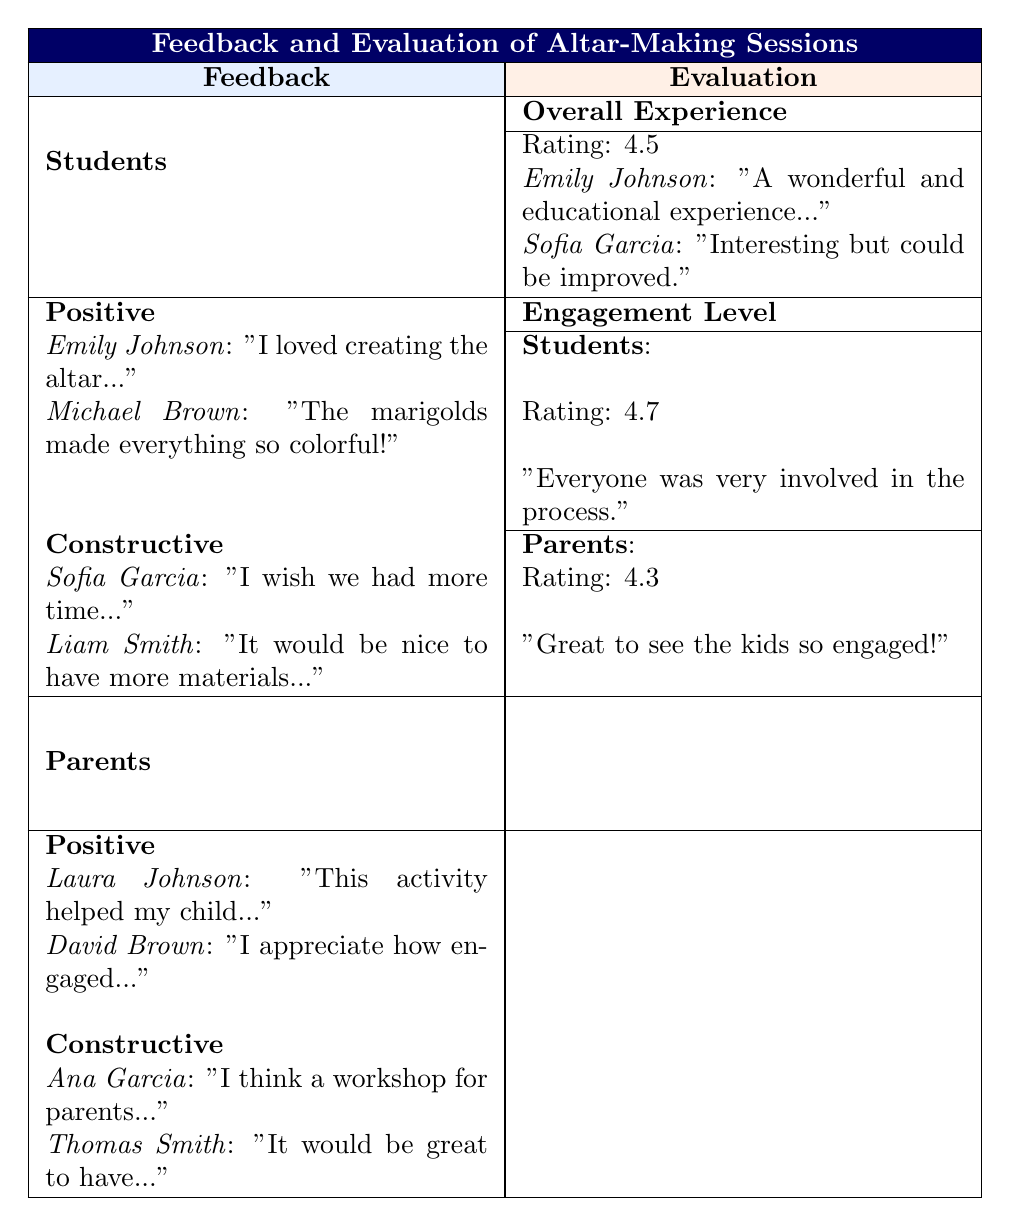What positive feedback did students provide about the altar-making session? Two students, Emily Johnson and Michael Brown, shared positive comments. Emily loved the experience of creating the altar and appreciated its beauty and tradition. Michael enjoyed the vibrant colors brought by the marigolds.
Answer: Emily Johnson and Michael Brown What was the engagement level rating from parents? The table shows that the engagement level rating from parents is 4.3, indicating a good level of engagement during the altar-making session.
Answer: 4.3 Did any parents suggest a workshop for themselves? Yes, Ana Garcia suggested that a workshop for parents would be beneficial to learn alongside their children during the altar-making session.
Answer: Yes What was the overall experience rating for the students? According to the table, the overall experience rating for students is 4.5, reflecting a generally positive response to the altar-making session.
Answer: 4.5 How do the engagement levels of students and parents compare? The students' engagement level is rated at 4.7, which is higher than the parents' engagement level of 4.3. This indicates that students felt more engaged than parents did during the session.
Answer: Students: 4.7; Parents: 4.3 What areas for improvement were noted by students? Constructive feedback from students included Sofia Garcia wishing for more time to learn about the traditions' stories and Liam Smith suggesting more crafting materials.
Answer: More time and more materials Calculate the difference between the overall experience rating and the students' engagement level. The students' overall experience rating is 4.5, while the engagement level is 4.7. The difference is 4.7 - 4.5 = 0.2, indicating that the engagement level was slightly higher than the overall experience rating.
Answer: 0.2 Was there any feedback indicating that students wanted more creative materials? Yes, Liam Smith expressed a wish for having more materials for crafting, highlighting a desire for additional creative resources.
Answer: Yes What did Laura Johnson appreciate about the altar-making activity? Laura Johnson appreciated that the activity helped her child connect with their heritage meaningfully, reflecting the positive impact of the experience.
Answer: Connection with heritage 